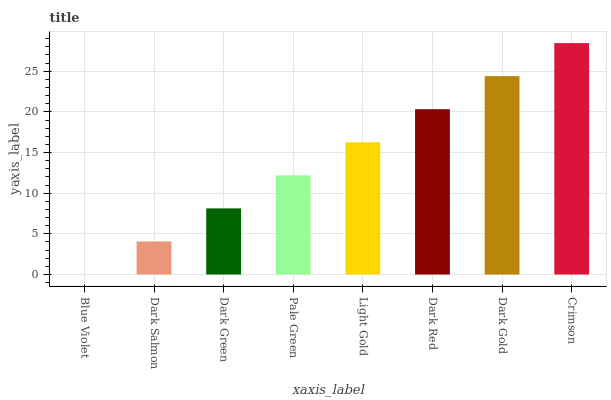Is Dark Salmon the minimum?
Answer yes or no. No. Is Dark Salmon the maximum?
Answer yes or no. No. Is Dark Salmon greater than Blue Violet?
Answer yes or no. Yes. Is Blue Violet less than Dark Salmon?
Answer yes or no. Yes. Is Blue Violet greater than Dark Salmon?
Answer yes or no. No. Is Dark Salmon less than Blue Violet?
Answer yes or no. No. Is Light Gold the high median?
Answer yes or no. Yes. Is Pale Green the low median?
Answer yes or no. Yes. Is Blue Violet the high median?
Answer yes or no. No. Is Light Gold the low median?
Answer yes or no. No. 